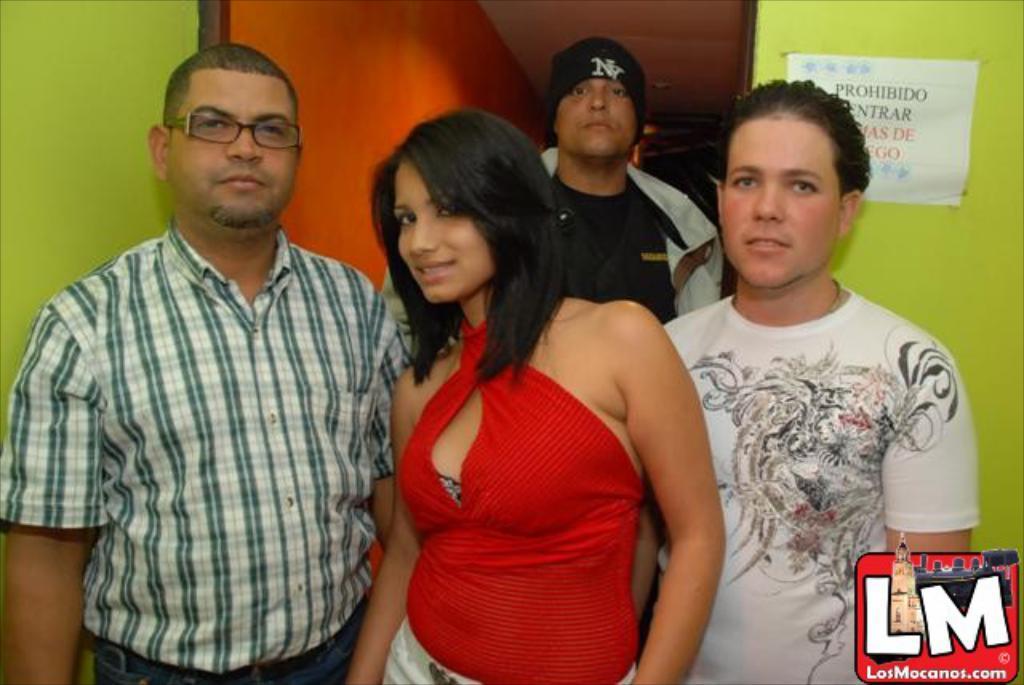Please provide a concise description of this image. In the picture we can see four people are standing there are men and one woman, one man is in shirt and one man is in T-shirt which is white in color with some designs on it and woman is with the red color dress and smiling and behind them, we can see a man with jacket, black T-shirt and cap and beside him we can see the orange color wall and besides it we can see the green color wall. 